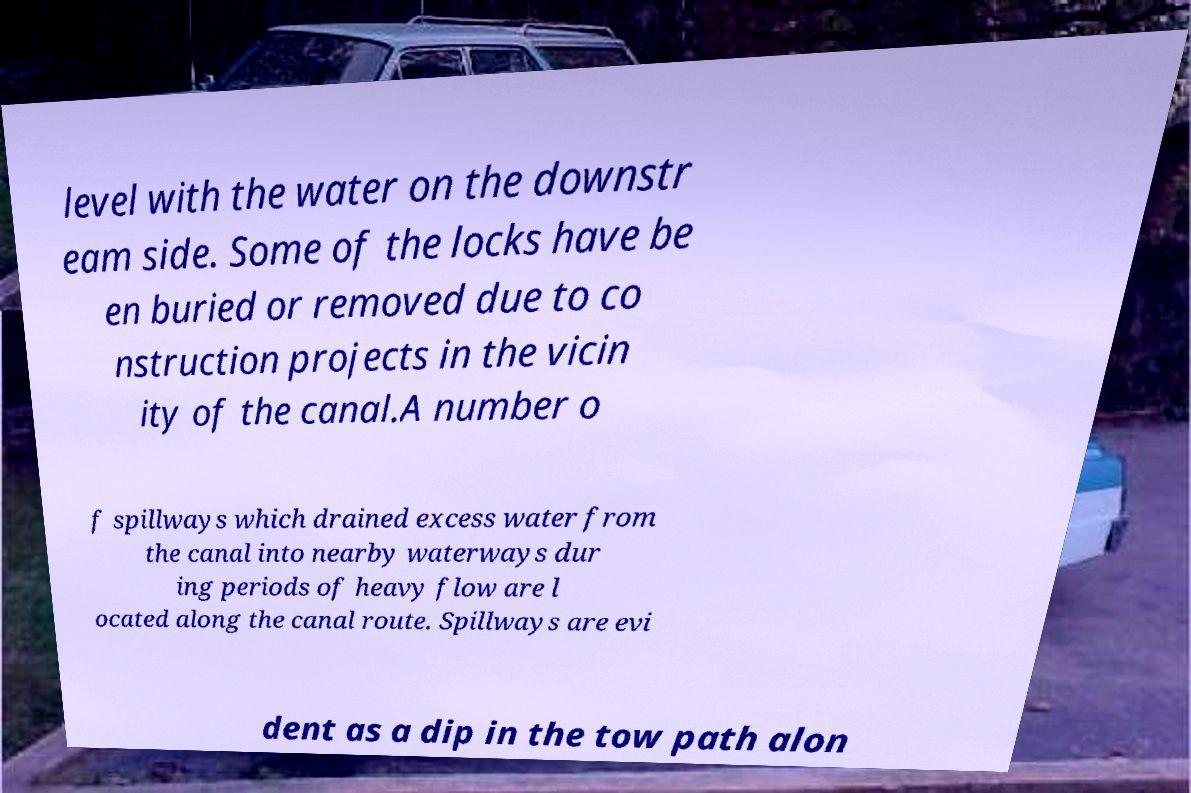I need the written content from this picture converted into text. Can you do that? level with the water on the downstr eam side. Some of the locks have be en buried or removed due to co nstruction projects in the vicin ity of the canal.A number o f spillways which drained excess water from the canal into nearby waterways dur ing periods of heavy flow are l ocated along the canal route. Spillways are evi dent as a dip in the tow path alon 